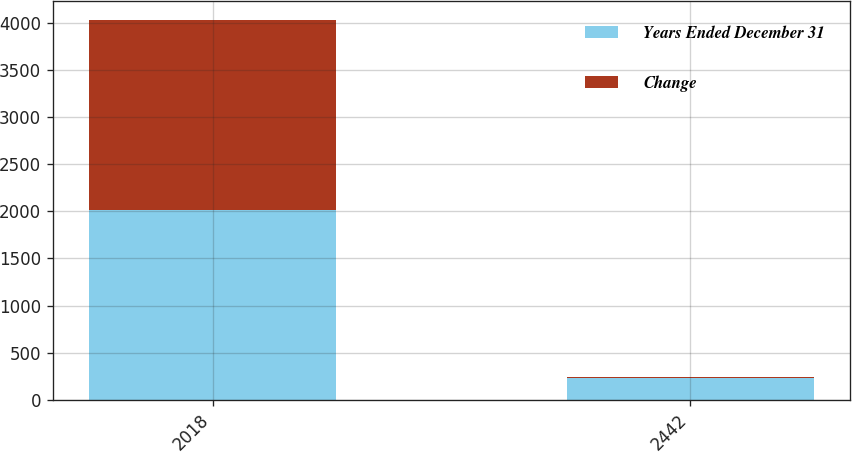Convert chart to OTSL. <chart><loc_0><loc_0><loc_500><loc_500><stacked_bar_chart><ecel><fcel>2018<fcel>2442<nl><fcel>Years Ended December 31<fcel>2017<fcel>235.1<nl><fcel>Change<fcel>2018<fcel>3.9<nl></chart> 